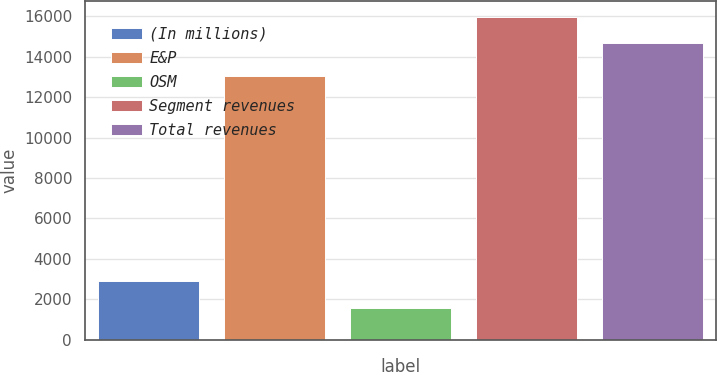Convert chart. <chart><loc_0><loc_0><loc_500><loc_500><bar_chart><fcel>(In millions)<fcel>E&P<fcel>OSM<fcel>Segment revenues<fcel>Total revenues<nl><fcel>2900.2<fcel>13029<fcel>1588<fcel>15975.2<fcel>14663<nl></chart> 